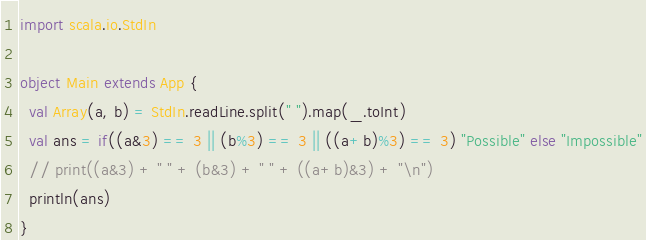<code> <loc_0><loc_0><loc_500><loc_500><_Scala_>import scala.io.StdIn

object Main extends App {
  val Array(a, b) = StdIn.readLine.split(" ").map(_.toInt)
  val ans = if((a&3) == 3 || (b%3) == 3 || ((a+b)%3) == 3) "Possible" else "Impossible"
  // print((a&3) + " " + (b&3) + " " + ((a+b)&3) + "\n")
  println(ans)
}</code> 